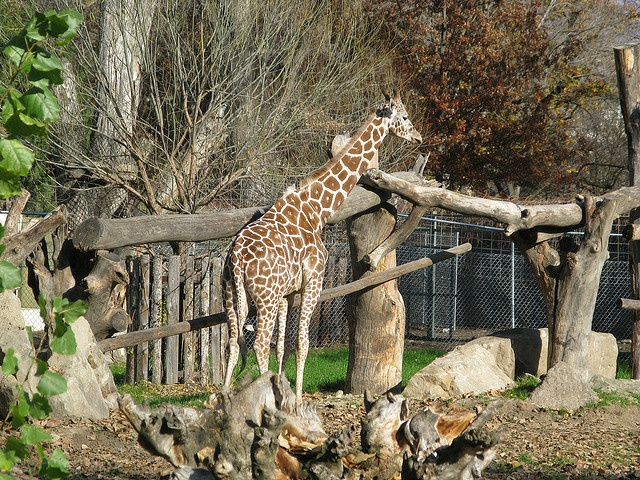Describe the objects in this image and their specific colors. I can see a giraffe in darkgreen, ivory, gray, brown, and tan tones in this image. 